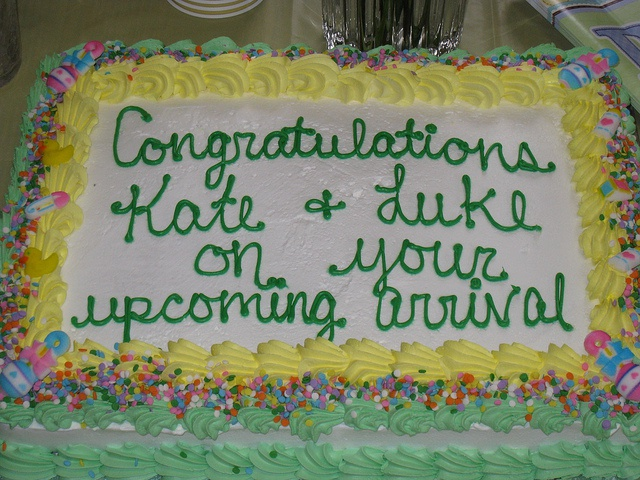Describe the objects in this image and their specific colors. I can see cake in darkgray, black, olive, teal, and darkgreen tones and cup in black, darkgreen, and gray tones in this image. 